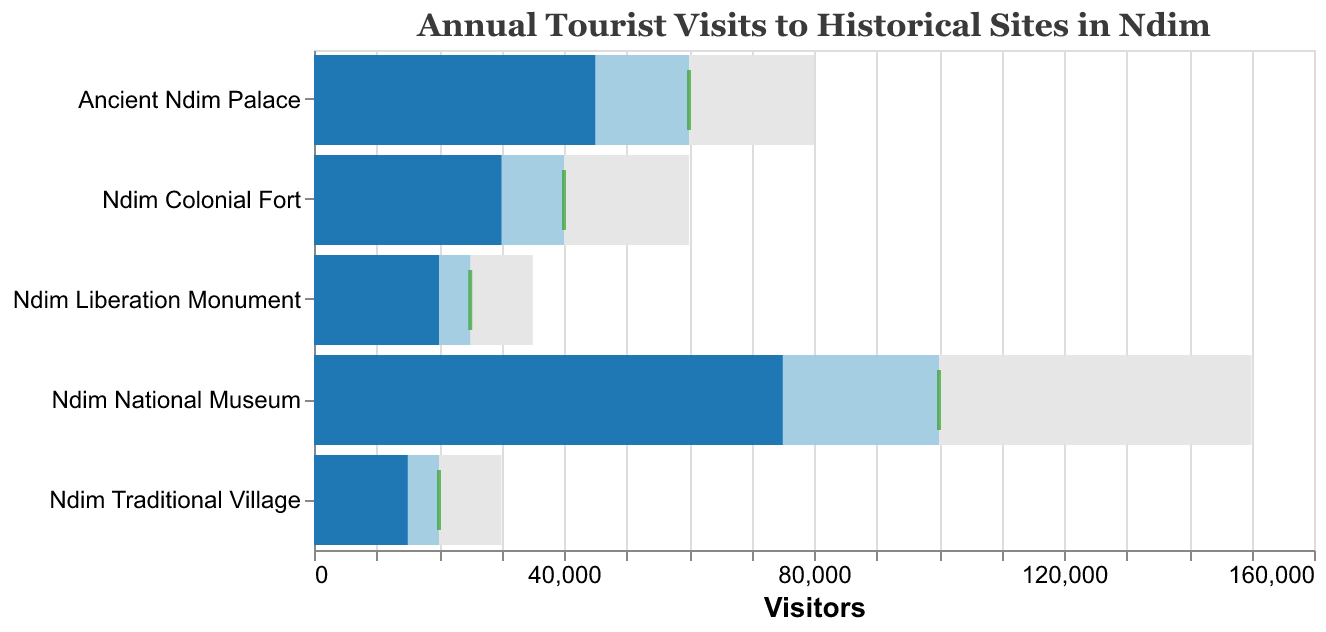What is the title of the figure? The title is at the top of the chart, reading "Annual Tourist Visits to Historical Sites in Ndim."
Answer: Annual Tourist Visits to Historical Sites in Ndim Which site has the highest actual visits? By looking at the bars colored in a darker blue, the Ndim National Museum has the highest actual visits bar.
Answer: Ndim National Museum How many sites have actual visits that meet or exceed their target visits? By checking the bars and their corresponding tick marks, no bars (actual visits) meet or exceed the tick marks (target visits).
Answer: 0 What's the difference between the target visits and the actual visits for Ancient Ndim Palace? The target visits for Ancient Ndim Palace are 60,000, and the actual visits are 45,000. The difference is 60,000 - 45,000 = 15,000.
Answer: 15,000 Which site has the smallest actual visits? The site with the smallest darker blue bar is the Ndim Traditional Village.
Answer: Ndim Traditional Village Compare the actual visits of Ndim Colonial Fort to its target visits. Are they more or less? By comparing the darker blue bar (actual visits) to the corresponding tick mark (target visits), actual visits (30,000) are less than target visits (40,000) for Ndim Colonial Fort.
Answer: Less What is the maximum capacity for Ndim Liberation Monument? The lightest grey bar for Ndim Liberation Monument extends to 35,000, which is its maximum capacity.
Answer: 35,000 Which site is closest to reaching its target visits based on the actual visits data? By visually comparing the actual visits bars to the target tick marks, Ndim Liberation Monument (20,000 actual vs. 25,000 target) appears the closest.
Answer: Ndim Liberation Monument How do the maximum capacities compare across all sites? The maximum capacities, represented by the lightest grey bars, range from 30,000 to 150,000. Ndim National Museum has the highest maximum capacity, while Ndim Traditional Village has the lowest.
Answer: Ranges from 30,000 to 150,000 